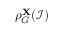<formula> <loc_0><loc_0><loc_500><loc_500>\rho _ { G } ^ { X } ( \mathcal { I } )</formula> 